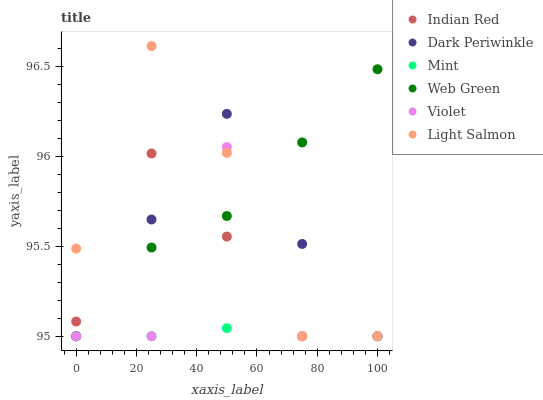Does Mint have the minimum area under the curve?
Answer yes or no. Yes. Does Web Green have the maximum area under the curve?
Answer yes or no. Yes. Does Indian Red have the minimum area under the curve?
Answer yes or no. No. Does Indian Red have the maximum area under the curve?
Answer yes or no. No. Is Mint the smoothest?
Answer yes or no. Yes. Is Violet the roughest?
Answer yes or no. Yes. Is Web Green the smoothest?
Answer yes or no. No. Is Web Green the roughest?
Answer yes or no. No. Does Light Salmon have the lowest value?
Answer yes or no. Yes. Does Light Salmon have the highest value?
Answer yes or no. Yes. Does Web Green have the highest value?
Answer yes or no. No. Does Web Green intersect Light Salmon?
Answer yes or no. Yes. Is Web Green less than Light Salmon?
Answer yes or no. No. Is Web Green greater than Light Salmon?
Answer yes or no. No. 